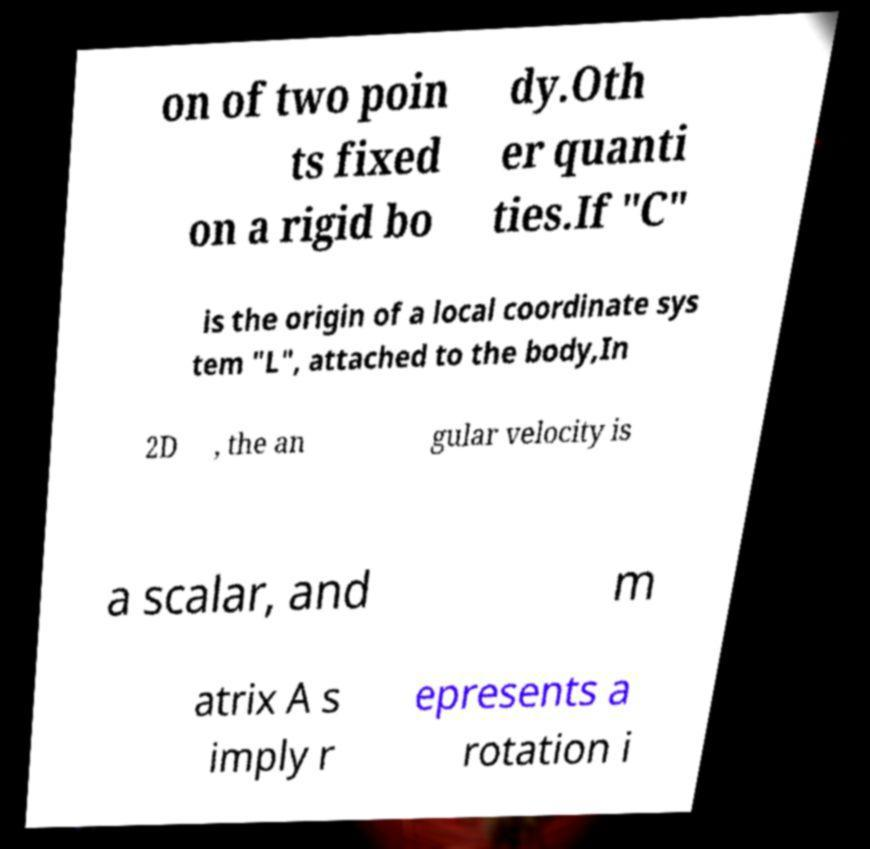Can you accurately transcribe the text from the provided image for me? on of two poin ts fixed on a rigid bo dy.Oth er quanti ties.If "C" is the origin of a local coordinate sys tem "L", attached to the body,In 2D , the an gular velocity is a scalar, and m atrix A s imply r epresents a rotation i 